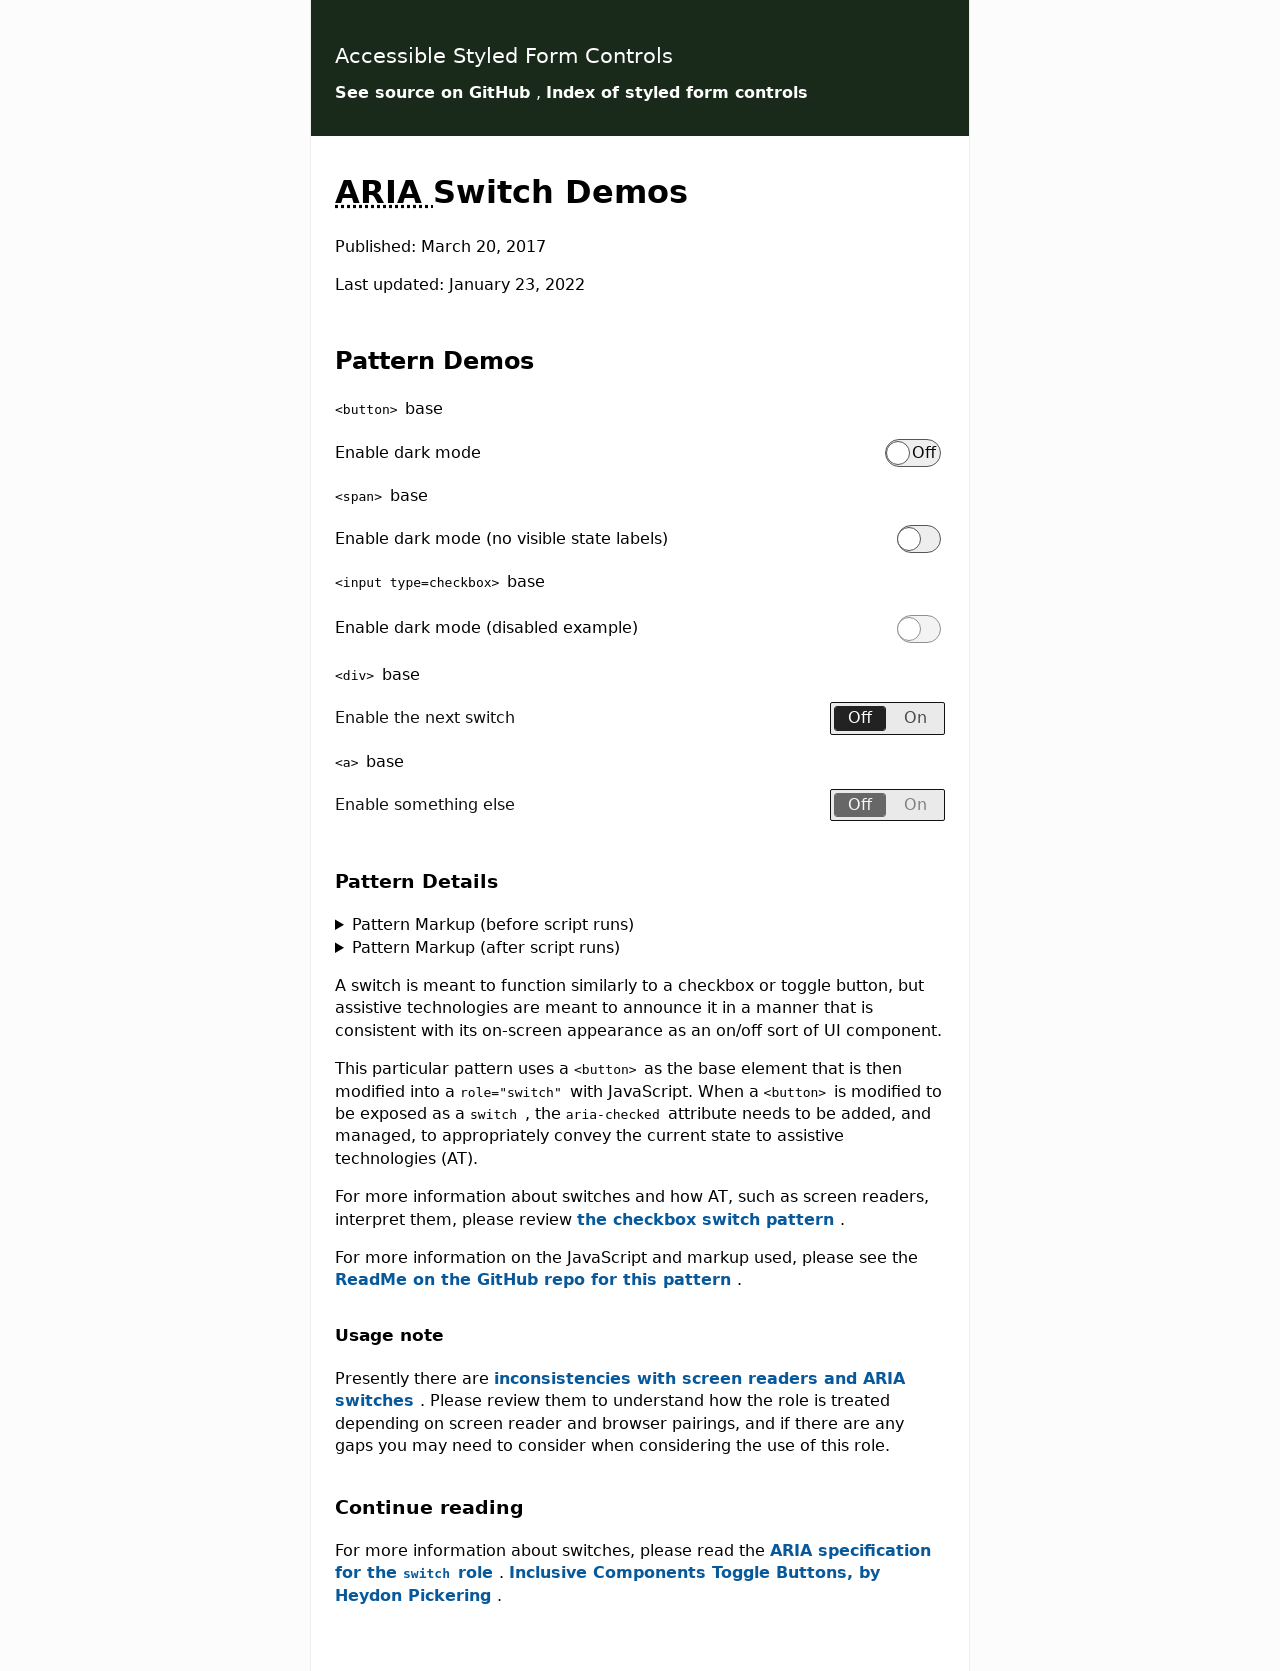Can you explain the importance of using ARIA roles in the switch components shown? ARIA roles are crucial for accessibility, especially for interactive components like switches. Using the `role='switch'` ensures that assistive technologies can correctly interpret the component as a toggleable switch rather than just a button. This helps users who rely on assistive devices to understand and manage the UI more effectively, providing a clearer indication of its function and current state. 